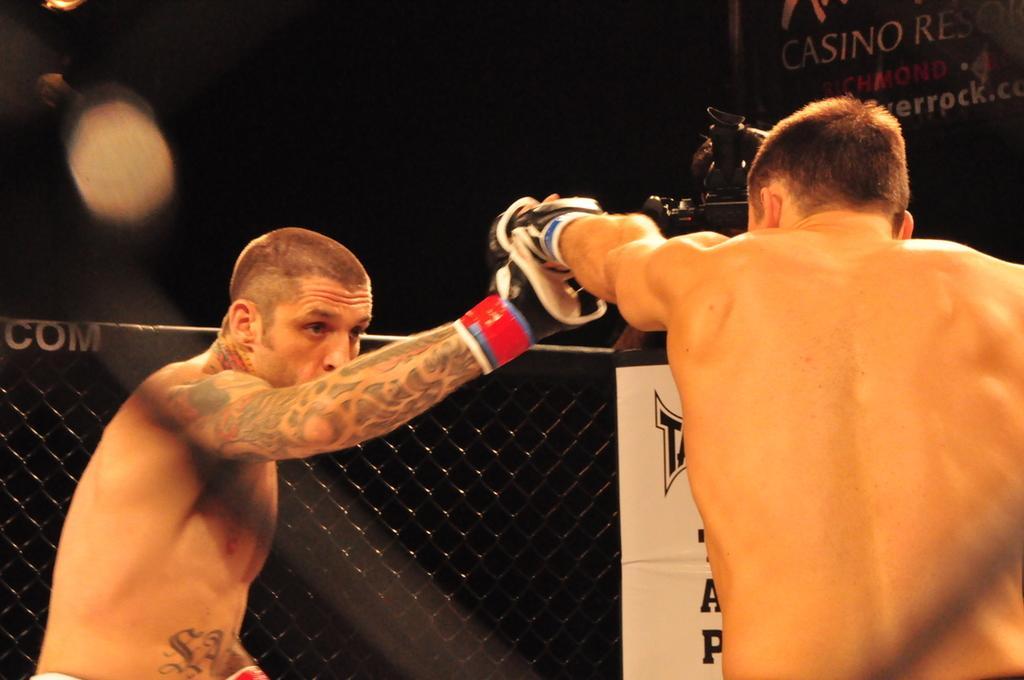Can you describe this image briefly? In this image we can see there are two persons fighting with each other, behind them there is a net fencing and a banner attached to it and there is a person shooting with a camera. On the top right side there is another banner with some text. 